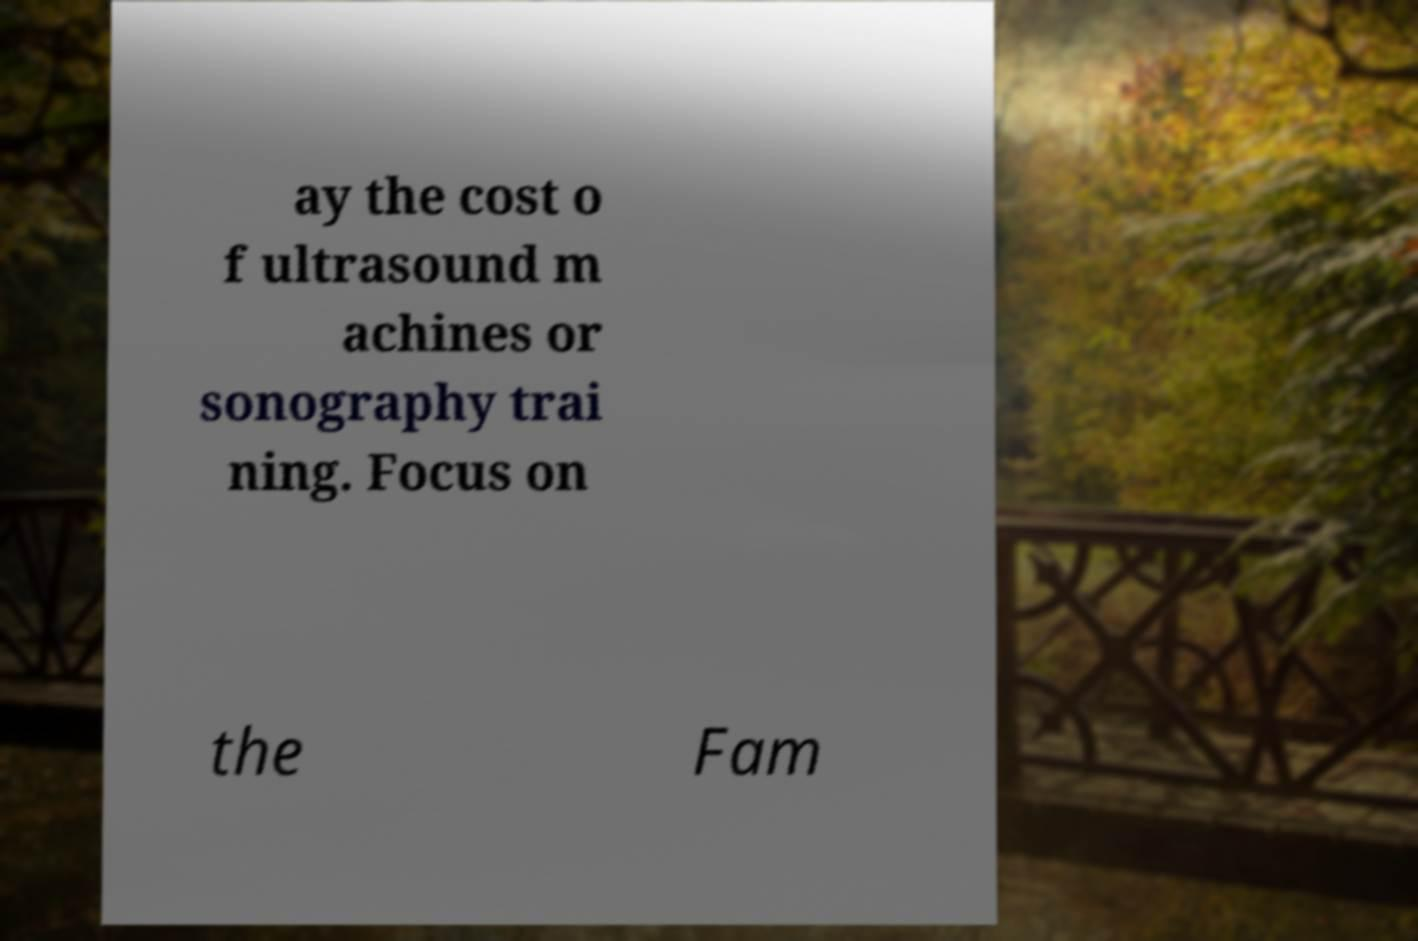Please identify and transcribe the text found in this image. ay the cost o f ultrasound m achines or sonography trai ning. Focus on the Fam 